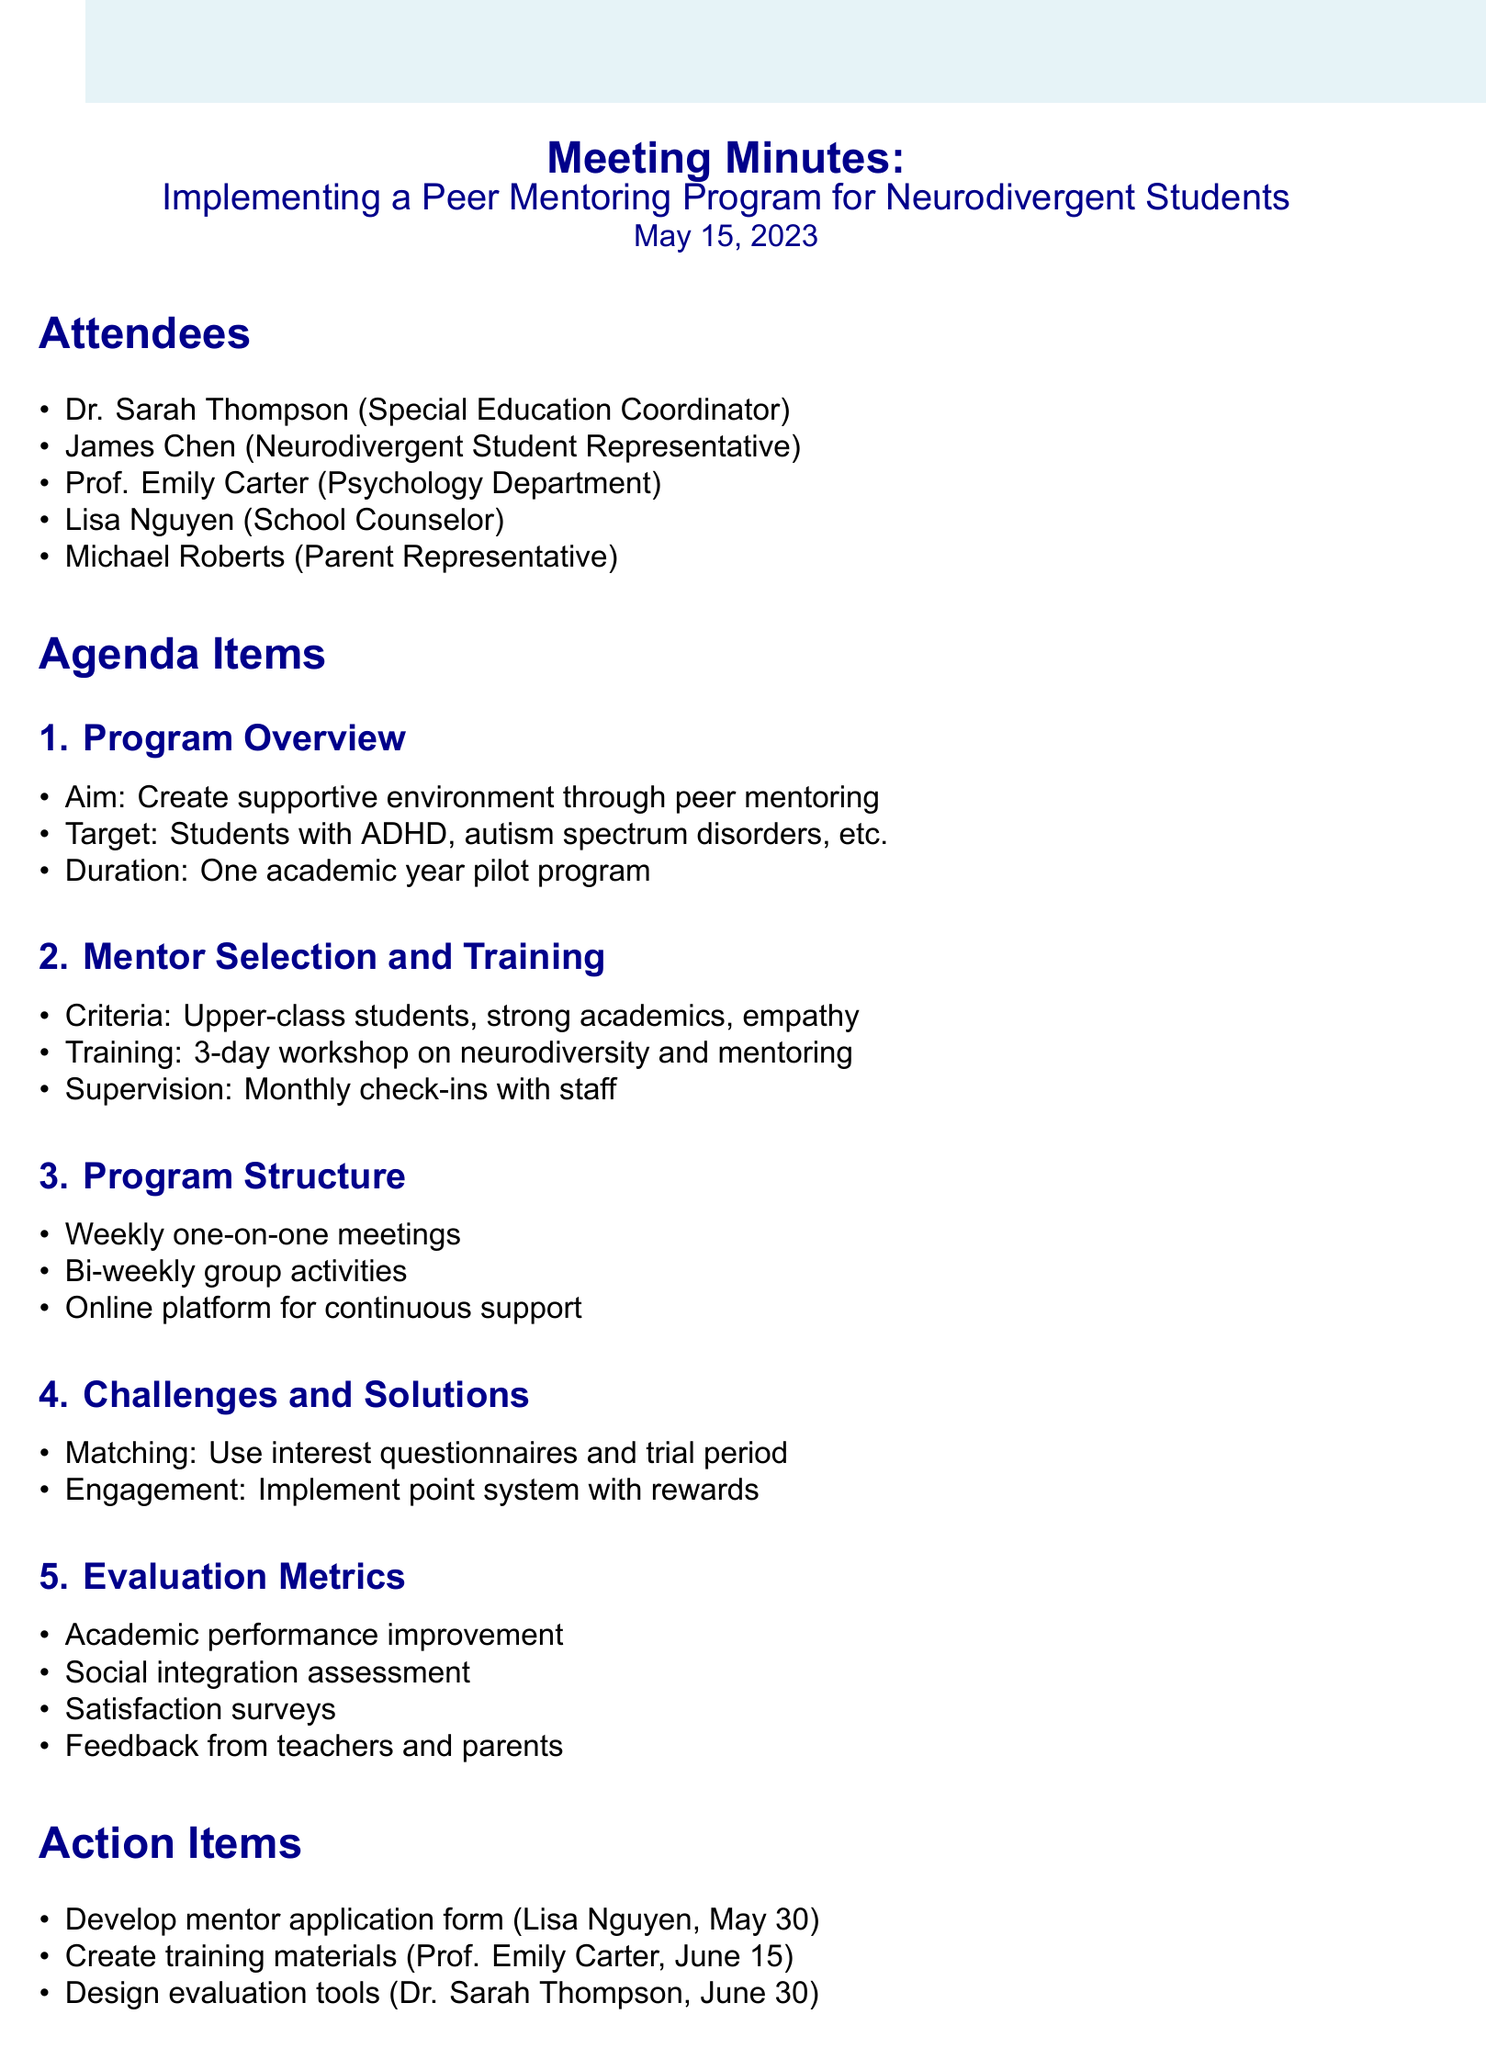What is the meeting title? The meeting title is stated clearly at the beginning of the document.
Answer: Implementing a Peer Mentoring Program for Neurodivergent Students Who is the Special Education Coordinator? The document lists the attendees along with their roles, which helps identify who holds that position.
Answer: Dr. Sarah Thompson What is the proposed duration of the pilot program? The agenda item on Program Overview specifies the duration of the program.
Answer: One academic year pilot program What is one criterion for mentor selection? The document outlines criteria for mentors under the Mentor Selection and Training agenda item.
Answer: Strong academic performance What are the monthly check-ins for? The document specifies the purpose of monthly check-ins under Mentor Selection and Training.
Answer: Supervision What challenge is mentioned regarding mentor-mentee matching? The document discusses challenges in the Potential Challenges and Solutions section.
Answer: Compatibility When is the next meeting scheduled? The next meeting details are provided at the end of the document.
Answer: June 5, 2023 Who is responsible for creating training materials? The action items section assigns tasks to specific attendees.
Answer: Prof. Emily Carter What is one evaluation metric mentioned? The Evaluation Metrics section lists different metrics to assess the program.
Answer: Academic performance improvement 